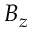Convert formula to latex. <formula><loc_0><loc_0><loc_500><loc_500>B _ { z }</formula> 